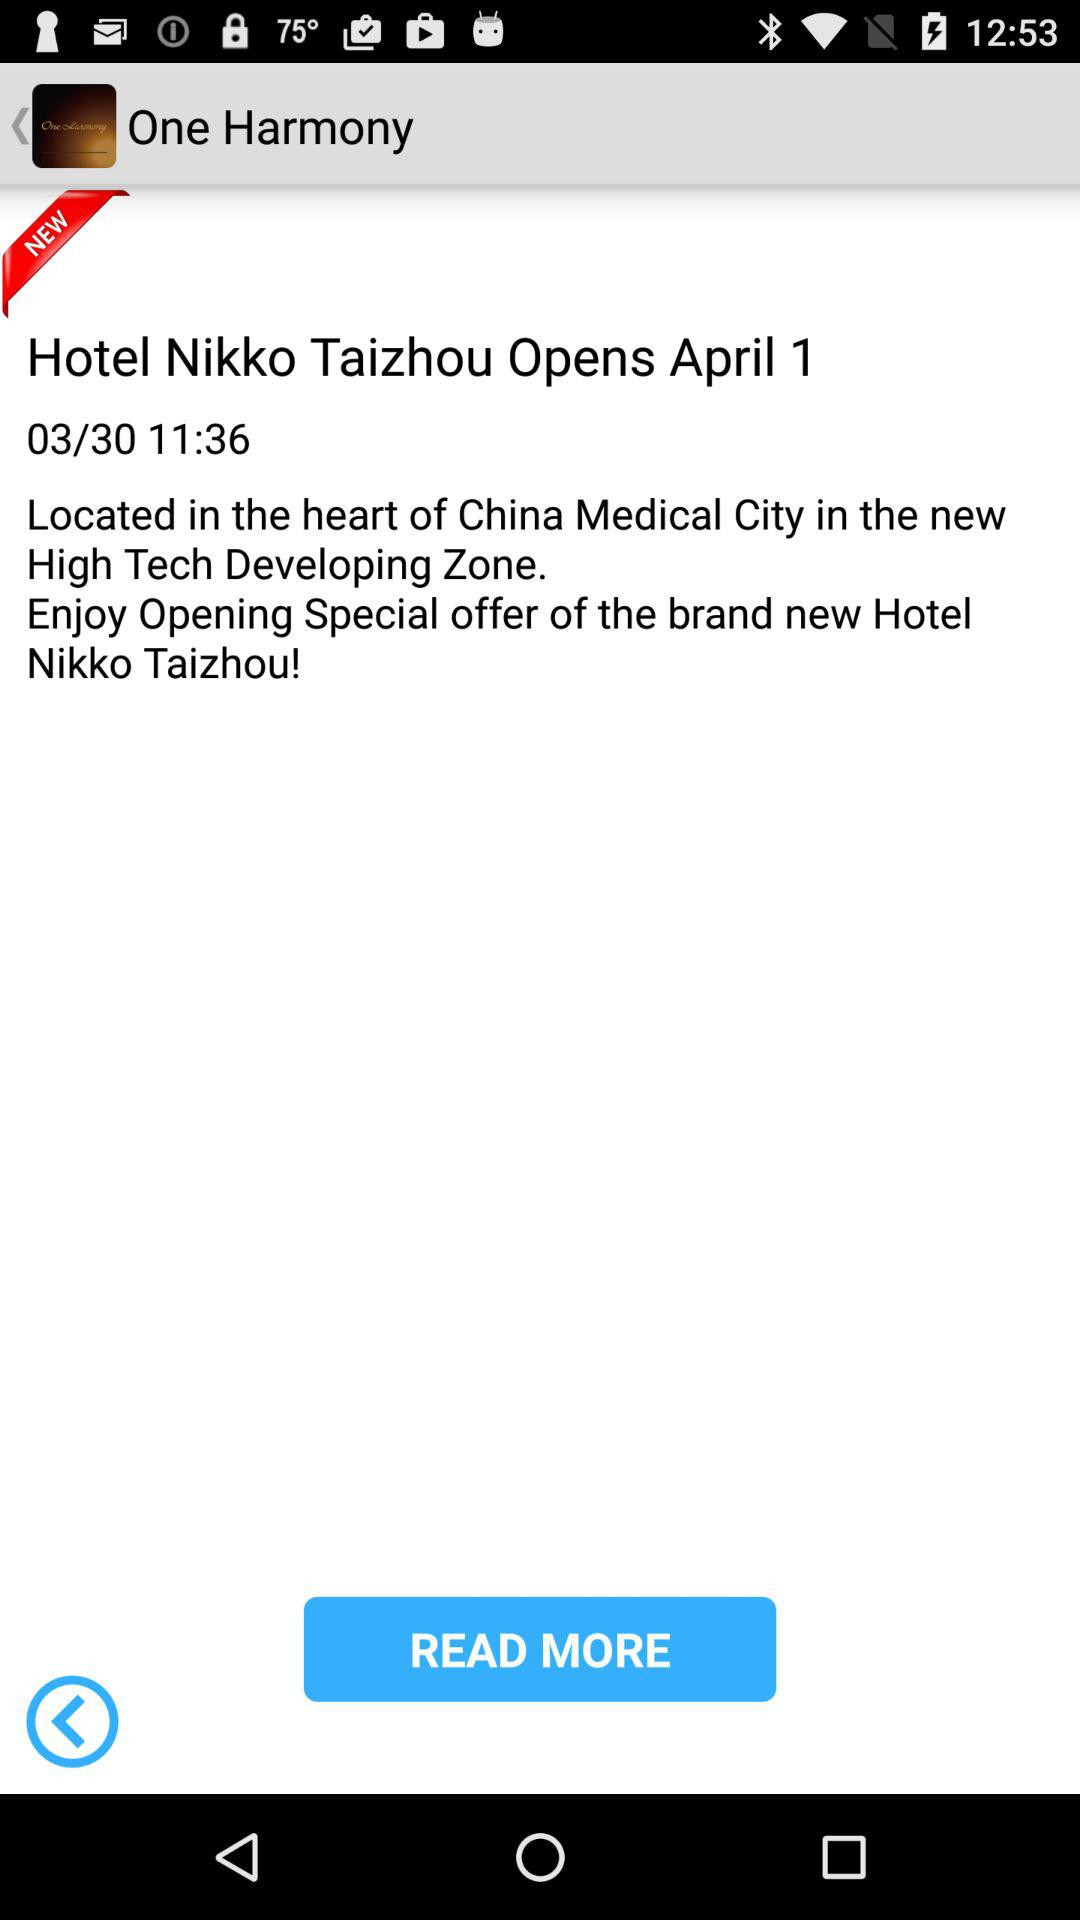At what time the hotel opening is done?
When the provided information is insufficient, respond with <no answer>. <no answer> 